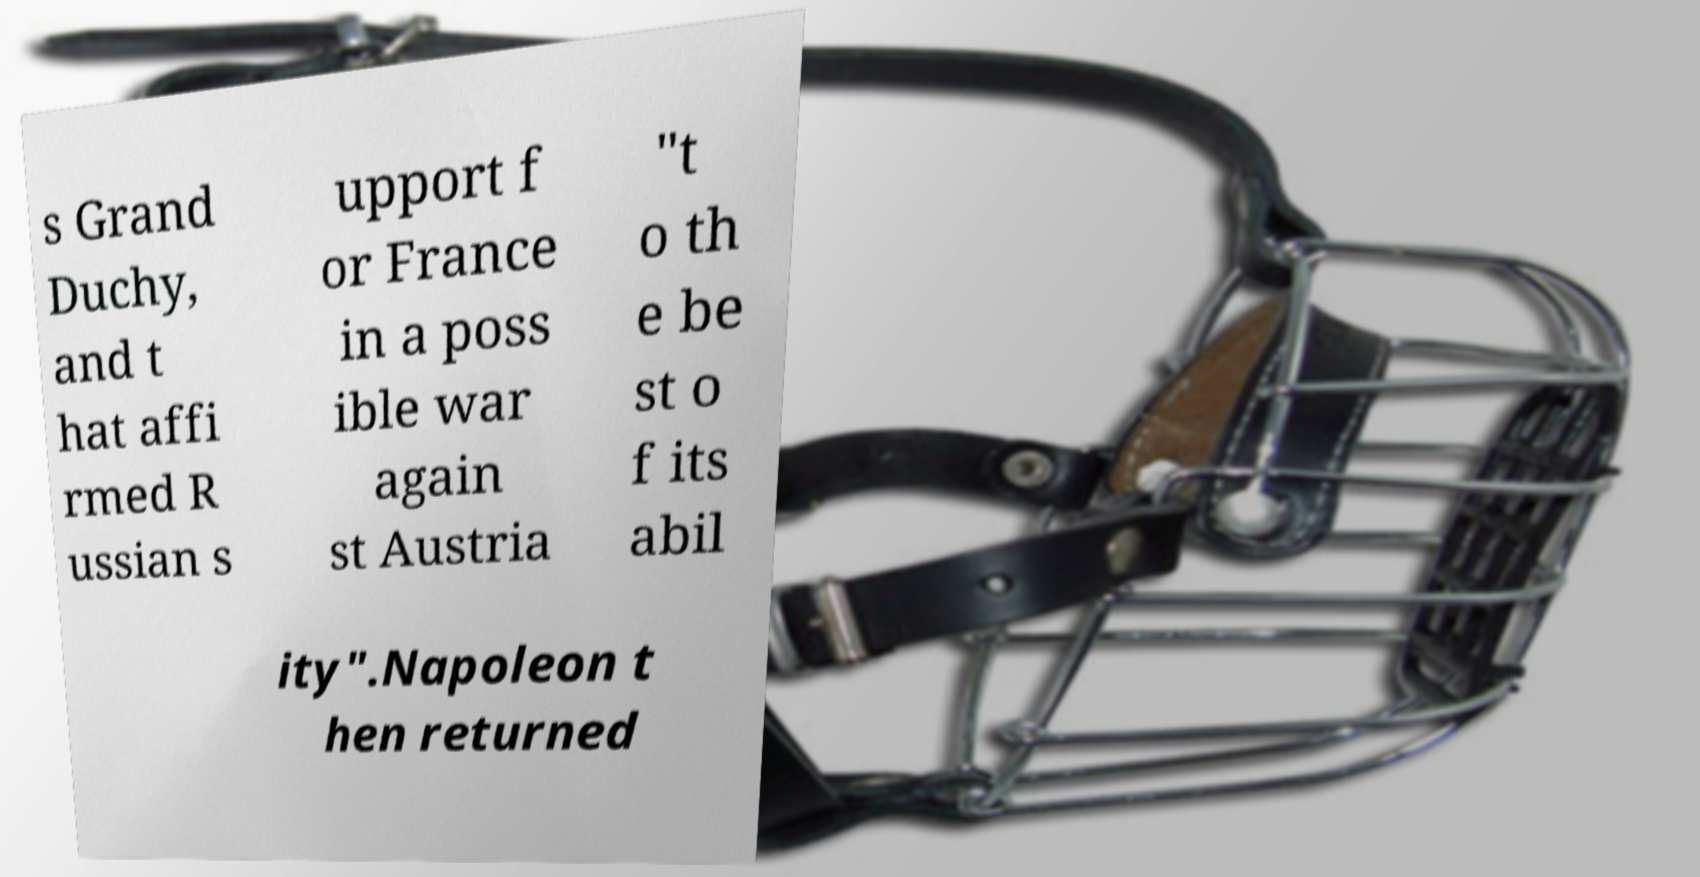Please read and relay the text visible in this image. What does it say? s Grand Duchy, and t hat affi rmed R ussian s upport f or France in a poss ible war again st Austria "t o th e be st o f its abil ity".Napoleon t hen returned 